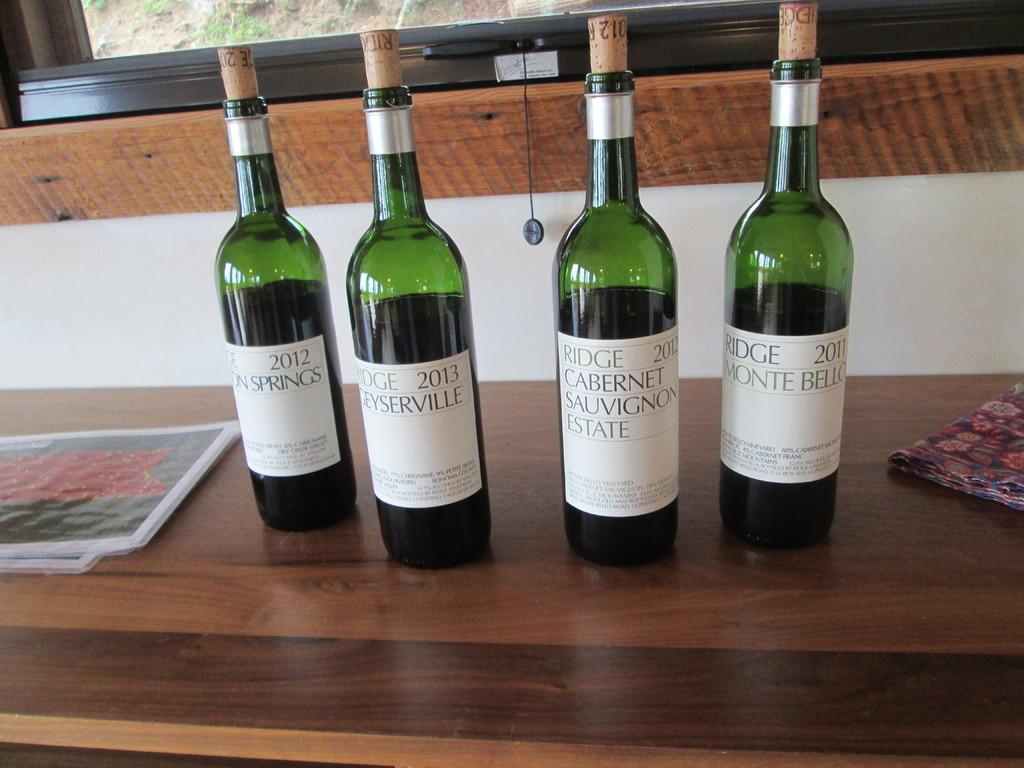Provide a one-sentence caption for the provided image. Four bottles of wine, all from different estates and springs. 